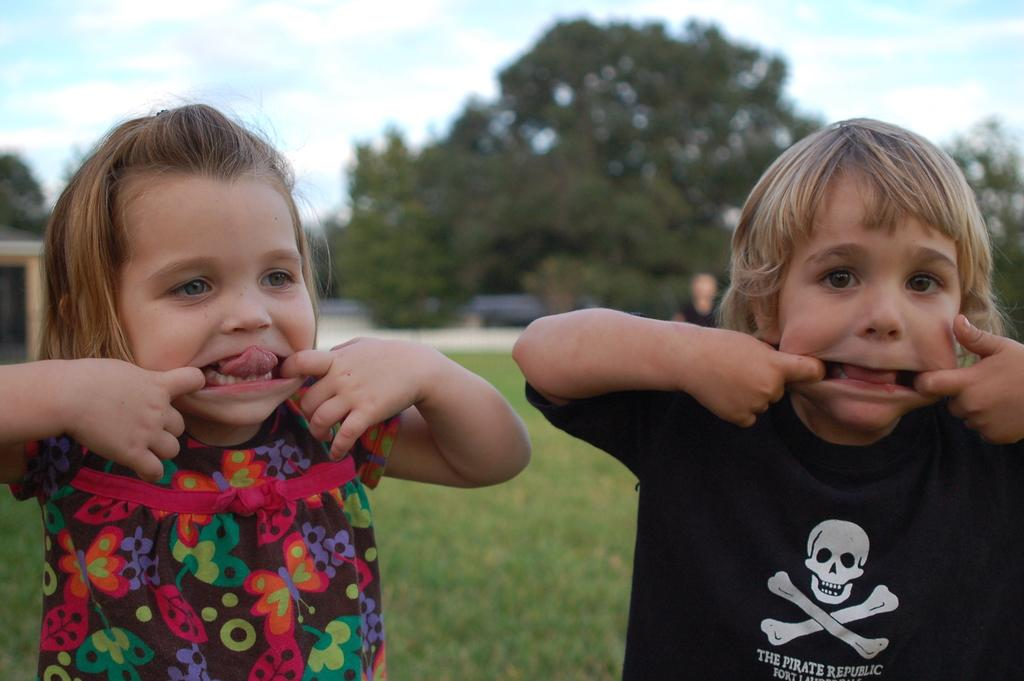How many kids are in the image? There are two kids in the image. What is at the bottom of the image? There is grass at the bottom of the image. What can be seen in the background of the image? There are trees and the sky visible in the background of the image. What type of bead is being used by the kids to form an organization in the image? There is no bead or organization present in the image. What channel is the kids watching in the image? There is no television or channel visible in the image. 